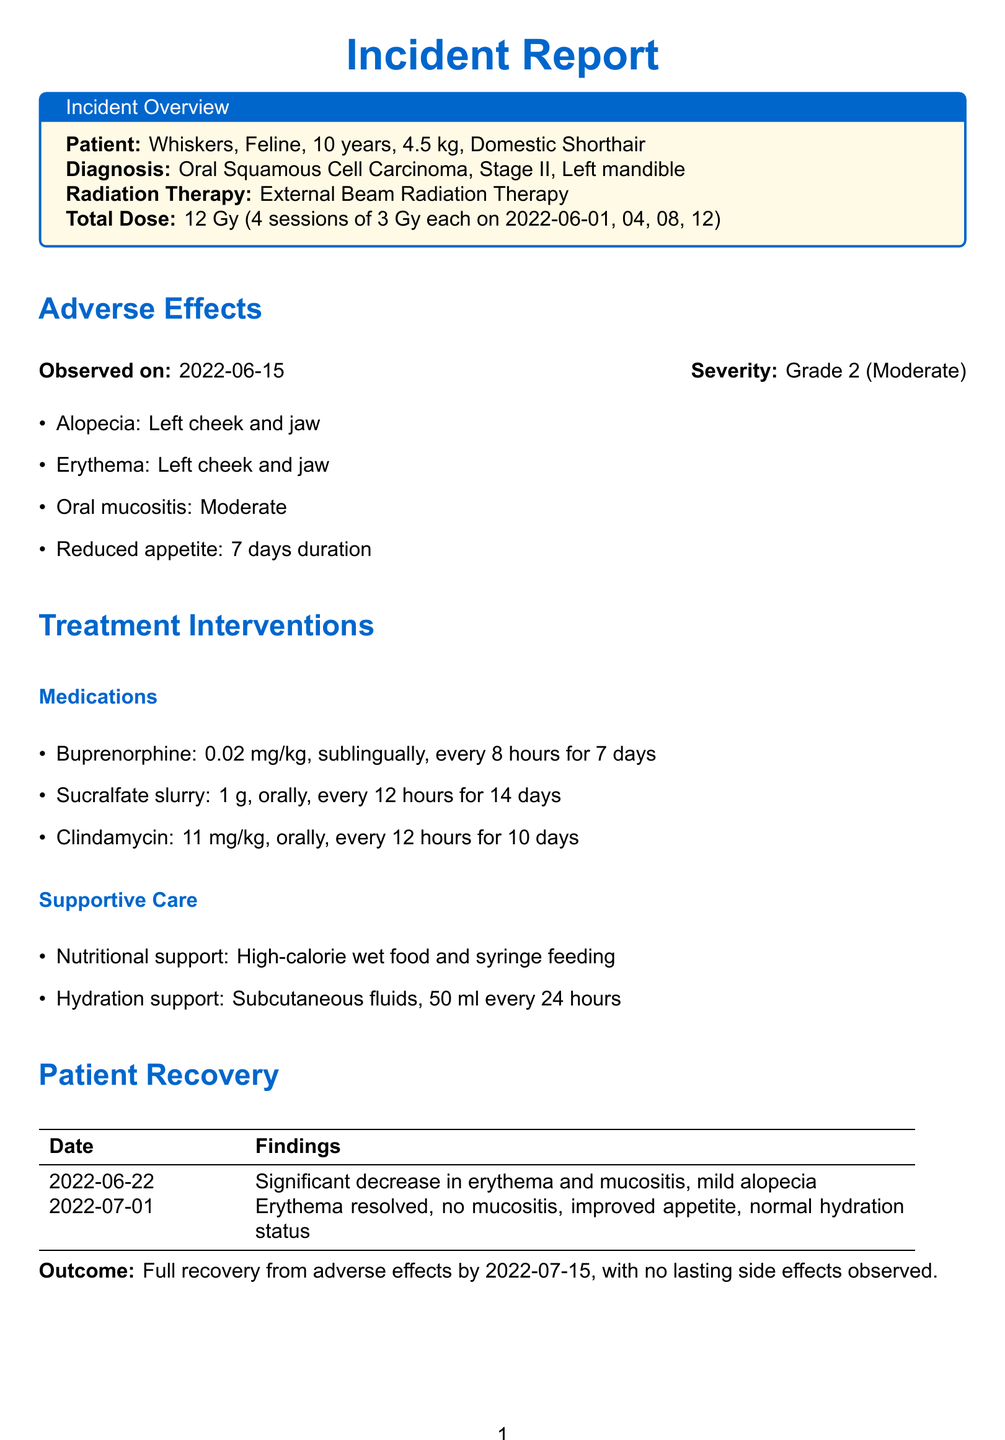What is the patient's name? The patient's name is provided at the beginning of the document under the Incident Overview section.
Answer: Whiskers What is the diagnosis of the patient? The diagnosis is stated in the Incident Overview section, detailing the condition affecting the patient.
Answer: Oral Squamous Cell Carcinoma, Stage II What was the total radiation dose administered? The total radiation dose is mentioned in the Incident Overview section, reflecting the entire treatment.
Answer: 12 Gy What adverse effect was observed on June 15, 2022? This information is specifically listed under the Adverse Effects section, highlighting one of the problems identified.
Answer: Alopecia How long did the reduced appetite last? The duration of the reduced appetite is noted in the Adverse Effects section of the document.
Answer: 7 days What medication was given for pain management? The specific medication for pain management is listed in the Treatment Interventions section.
Answer: Buprenorphine On what date was significant recovery noted? The recovery date is indicated in the Patient Recovery table within the document.
Answer: 2022-06-22 What suggested protocol adjustment involves client education? This adjustment is listed in the Protocol Adjustments section, focusing on enhancing client awareness.
Answer: Enhanced client education on signs of adverse reactions What is the patient's weight? The patient's weight is provided in the Incident Overview section of the document.
Answer: 4.5 kg 